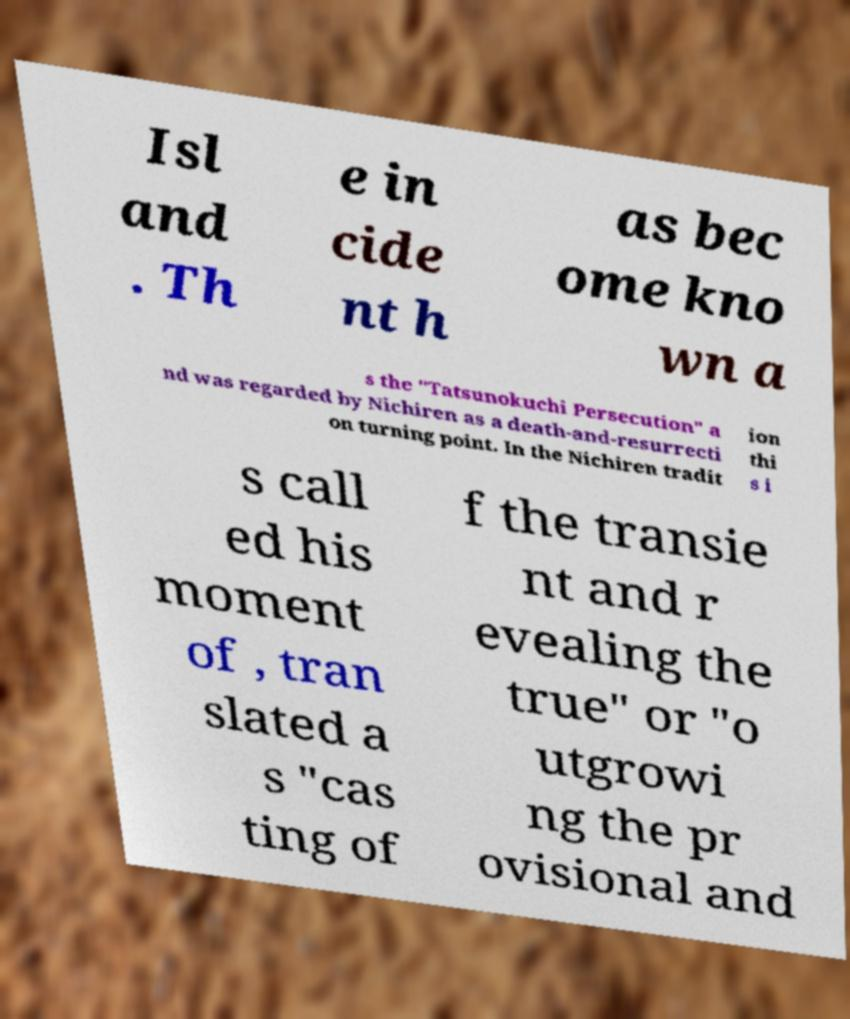Can you read and provide the text displayed in the image?This photo seems to have some interesting text. Can you extract and type it out for me? Isl and . Th e in cide nt h as bec ome kno wn a s the "Tatsunokuchi Persecution" a nd was regarded by Nichiren as a death-and-resurrecti on turning point. In the Nichiren tradit ion thi s i s call ed his moment of , tran slated a s "cas ting of f the transie nt and r evealing the true" or "o utgrowi ng the pr ovisional and 